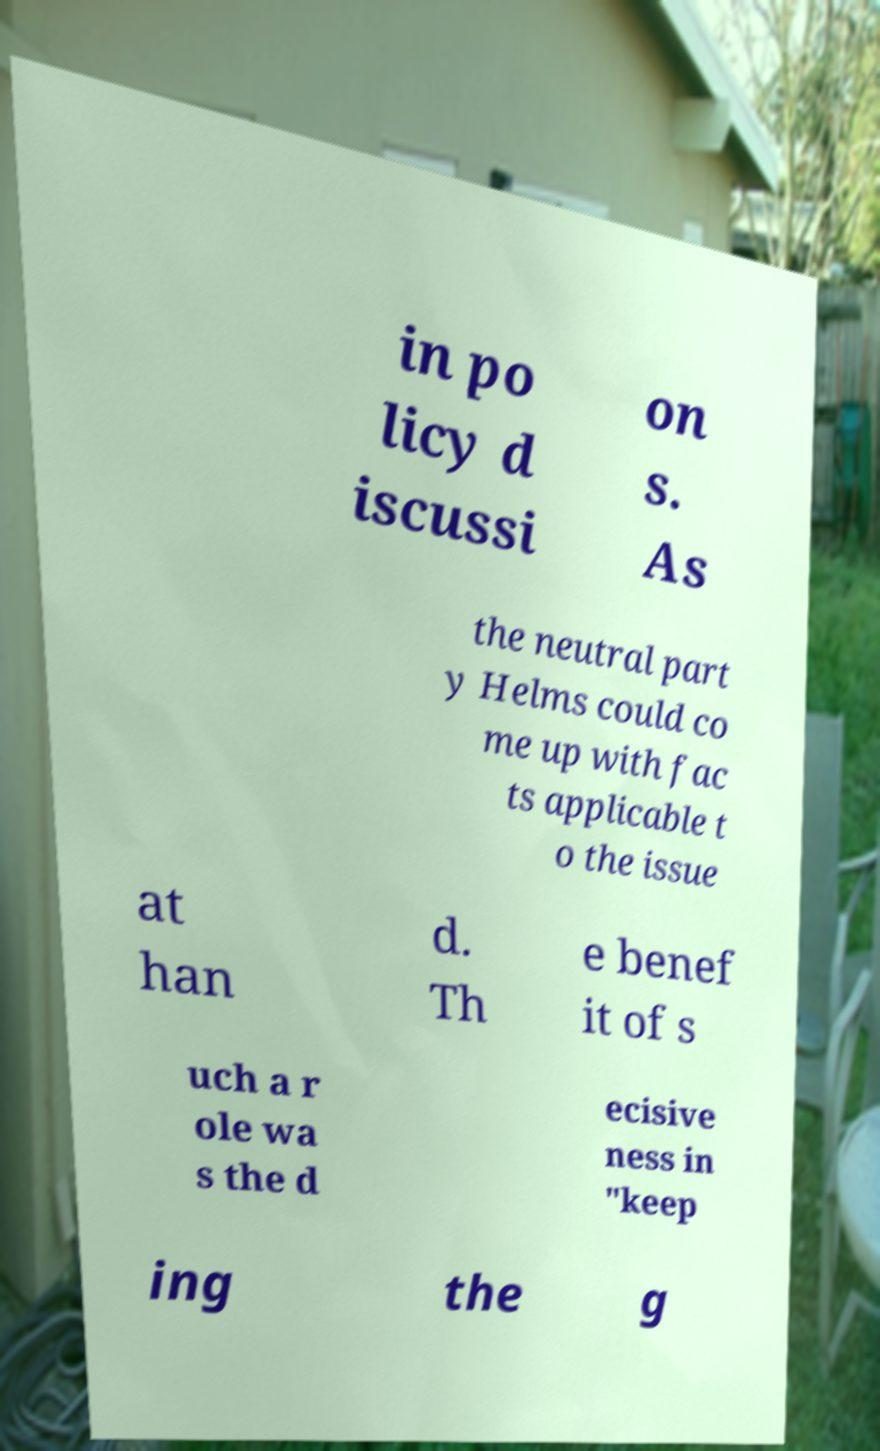Could you assist in decoding the text presented in this image and type it out clearly? in po licy d iscussi on s. As the neutral part y Helms could co me up with fac ts applicable t o the issue at han d. Th e benef it of s uch a r ole wa s the d ecisive ness in "keep ing the g 